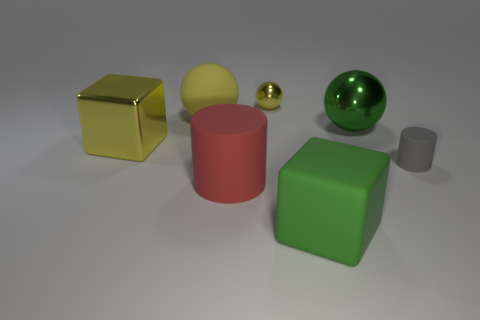What material is the big red thing that is the same shape as the gray thing?
Offer a terse response. Rubber. There is a large metal object right of the small shiny object; what shape is it?
Provide a succinct answer. Sphere. Is there a large red object made of the same material as the gray object?
Provide a succinct answer. Yes. Do the green sphere and the green matte cube have the same size?
Offer a terse response. Yes. How many cylinders are tiny shiny objects or cyan matte things?
Offer a very short reply. 0. There is a object that is the same color as the large metallic sphere; what is it made of?
Offer a very short reply. Rubber. What number of green objects are the same shape as the big yellow matte thing?
Make the answer very short. 1. Is the number of yellow rubber spheres that are in front of the big cylinder greater than the number of spheres that are behind the gray rubber object?
Your answer should be very brief. No. There is a large metal object in front of the green sphere; does it have the same color as the large matte cylinder?
Make the answer very short. No. What is the size of the green shiny ball?
Ensure brevity in your answer.  Large. 